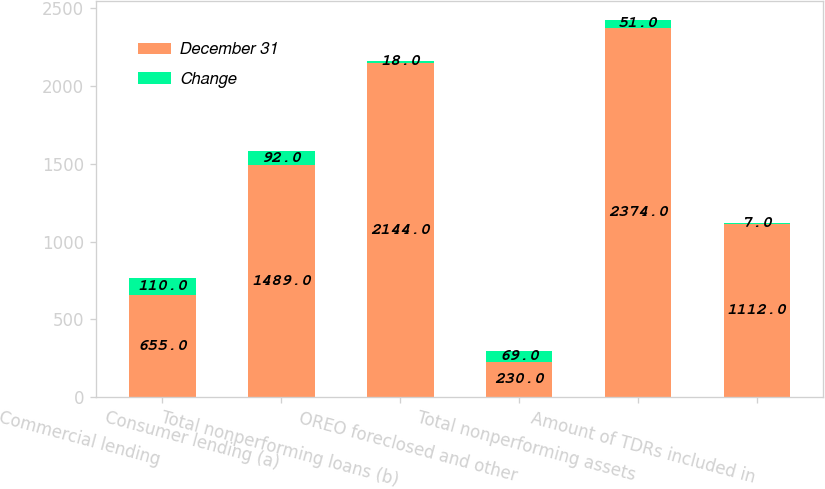<chart> <loc_0><loc_0><loc_500><loc_500><stacked_bar_chart><ecel><fcel>Commercial lending<fcel>Consumer lending (a)<fcel>Total nonperforming loans (b)<fcel>OREO foreclosed and other<fcel>Total nonperforming assets<fcel>Amount of TDRs included in<nl><fcel>December 31<fcel>655<fcel>1489<fcel>2144<fcel>230<fcel>2374<fcel>1112<nl><fcel>Change<fcel>110<fcel>92<fcel>18<fcel>69<fcel>51<fcel>7<nl></chart> 